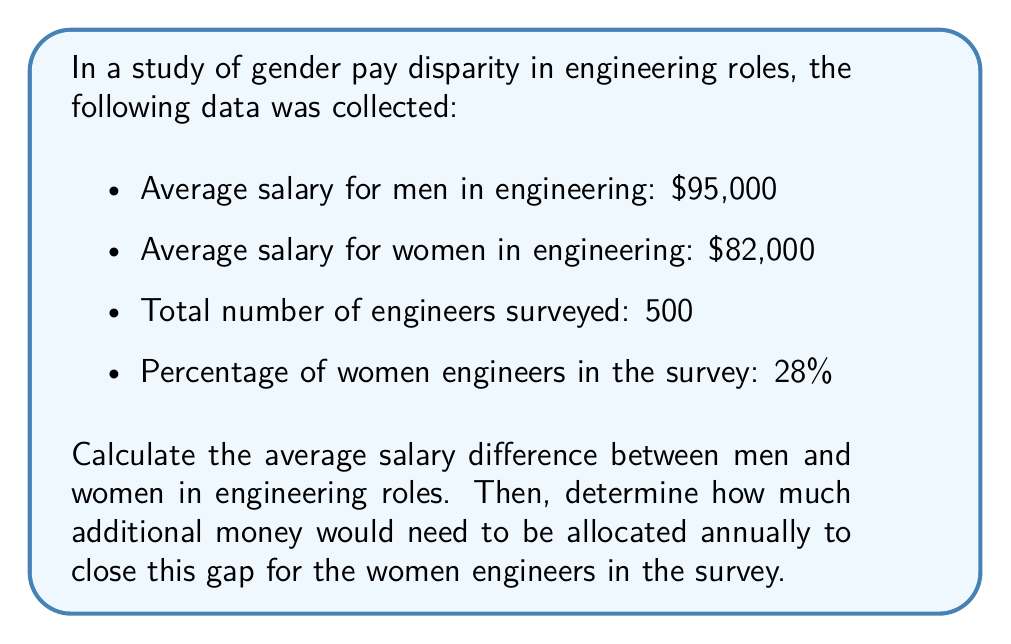Can you answer this question? Let's approach this problem step-by-step:

1. Calculate the salary difference:
   $$\text{Salary difference} = \text{Men's average salary} - \text{Women's average salary}$$
   $$\text{Salary difference} = \$95,000 - \$82,000 = \$13,000$$

2. Calculate the number of women engineers in the survey:
   $$\text{Number of women} = 28\% \text{ of } 500 = 0.28 \times 500 = 140 \text{ women}$$

3. Calculate the total amount needed to close the gap:
   $$\text{Total amount} = \text{Salary difference} \times \text{Number of women}$$
   $$\text{Total amount} = \$13,000 \times 140 = \$1,820,000$$

This calculation shows that to close the gender pay gap for the women engineers in this survey, an additional $1,820,000 would need to be allocated annually.

It's important to note that this calculation assumes that closing the gap means raising women's salaries to match men's, rather than adjusting both to meet at a middle point. In practice, addressing pay equity is more complex and may involve various strategies beyond simple salary adjustments.
Answer: The average salary difference between men and women in engineering roles is $13,000. To close this gap for the women engineers in the survey, an additional $1,820,000 would need to be allocated annually. 